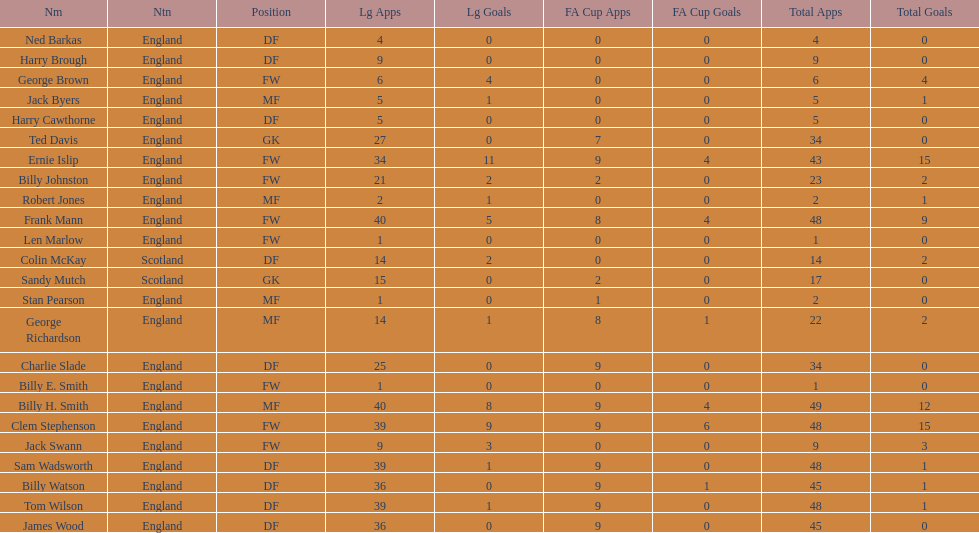How many players are fws? 8. 